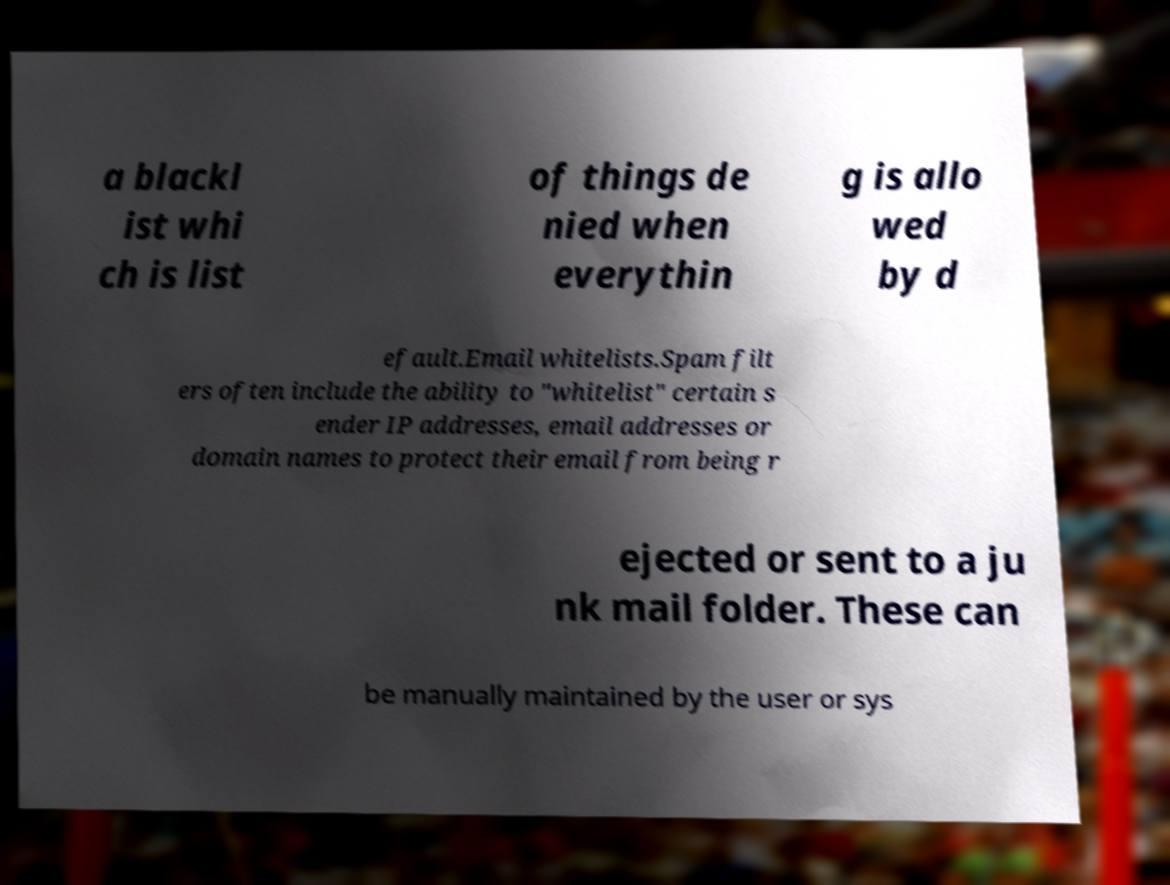What messages or text are displayed in this image? I need them in a readable, typed format. a blackl ist whi ch is list of things de nied when everythin g is allo wed by d efault.Email whitelists.Spam filt ers often include the ability to "whitelist" certain s ender IP addresses, email addresses or domain names to protect their email from being r ejected or sent to a ju nk mail folder. These can be manually maintained by the user or sys 